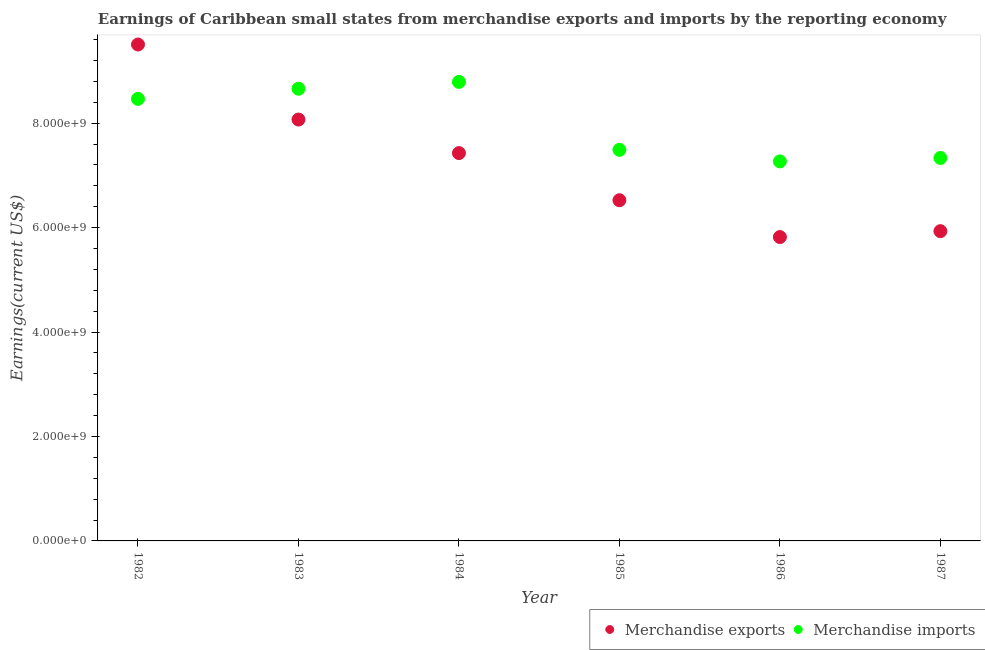What is the earnings from merchandise exports in 1984?
Your answer should be very brief. 7.43e+09. Across all years, what is the maximum earnings from merchandise imports?
Keep it short and to the point. 8.79e+09. Across all years, what is the minimum earnings from merchandise exports?
Your answer should be very brief. 5.82e+09. In which year was the earnings from merchandise exports maximum?
Offer a very short reply. 1982. What is the total earnings from merchandise exports in the graph?
Offer a terse response. 4.33e+1. What is the difference between the earnings from merchandise exports in 1983 and that in 1984?
Your response must be concise. 6.42e+08. What is the difference between the earnings from merchandise imports in 1982 and the earnings from merchandise exports in 1987?
Keep it short and to the point. 2.53e+09. What is the average earnings from merchandise imports per year?
Offer a terse response. 8.00e+09. In the year 1982, what is the difference between the earnings from merchandise imports and earnings from merchandise exports?
Offer a very short reply. -1.04e+09. What is the ratio of the earnings from merchandise exports in 1982 to that in 1983?
Provide a short and direct response. 1.18. Is the earnings from merchandise imports in 1985 less than that in 1987?
Offer a terse response. No. Is the difference between the earnings from merchandise imports in 1983 and 1986 greater than the difference between the earnings from merchandise exports in 1983 and 1986?
Your response must be concise. No. What is the difference between the highest and the second highest earnings from merchandise imports?
Your answer should be compact. 1.31e+08. What is the difference between the highest and the lowest earnings from merchandise imports?
Ensure brevity in your answer.  1.52e+09. In how many years, is the earnings from merchandise exports greater than the average earnings from merchandise exports taken over all years?
Offer a very short reply. 3. Is the sum of the earnings from merchandise exports in 1982 and 1985 greater than the maximum earnings from merchandise imports across all years?
Your answer should be compact. Yes. Is the earnings from merchandise imports strictly greater than the earnings from merchandise exports over the years?
Ensure brevity in your answer.  No. How many dotlines are there?
Provide a succinct answer. 2. How many years are there in the graph?
Your answer should be compact. 6. Are the values on the major ticks of Y-axis written in scientific E-notation?
Your answer should be compact. Yes. Does the graph contain any zero values?
Your response must be concise. No. Where does the legend appear in the graph?
Your answer should be compact. Bottom right. How many legend labels are there?
Give a very brief answer. 2. What is the title of the graph?
Keep it short and to the point. Earnings of Caribbean small states from merchandise exports and imports by the reporting economy. Does "Male population" appear as one of the legend labels in the graph?
Offer a very short reply. No. What is the label or title of the Y-axis?
Ensure brevity in your answer.  Earnings(current US$). What is the Earnings(current US$) of Merchandise exports in 1982?
Your answer should be compact. 9.51e+09. What is the Earnings(current US$) in Merchandise imports in 1982?
Make the answer very short. 8.47e+09. What is the Earnings(current US$) in Merchandise exports in 1983?
Offer a terse response. 8.07e+09. What is the Earnings(current US$) of Merchandise imports in 1983?
Make the answer very short. 8.66e+09. What is the Earnings(current US$) of Merchandise exports in 1984?
Your answer should be compact. 7.43e+09. What is the Earnings(current US$) in Merchandise imports in 1984?
Your answer should be compact. 8.79e+09. What is the Earnings(current US$) of Merchandise exports in 1985?
Your answer should be very brief. 6.53e+09. What is the Earnings(current US$) of Merchandise imports in 1985?
Offer a very short reply. 7.49e+09. What is the Earnings(current US$) in Merchandise exports in 1986?
Your answer should be very brief. 5.82e+09. What is the Earnings(current US$) of Merchandise imports in 1986?
Your response must be concise. 7.27e+09. What is the Earnings(current US$) of Merchandise exports in 1987?
Your answer should be very brief. 5.93e+09. What is the Earnings(current US$) in Merchandise imports in 1987?
Give a very brief answer. 7.33e+09. Across all years, what is the maximum Earnings(current US$) in Merchandise exports?
Keep it short and to the point. 9.51e+09. Across all years, what is the maximum Earnings(current US$) in Merchandise imports?
Keep it short and to the point. 8.79e+09. Across all years, what is the minimum Earnings(current US$) in Merchandise exports?
Your answer should be compact. 5.82e+09. Across all years, what is the minimum Earnings(current US$) in Merchandise imports?
Provide a succinct answer. 7.27e+09. What is the total Earnings(current US$) of Merchandise exports in the graph?
Your answer should be very brief. 4.33e+1. What is the total Earnings(current US$) in Merchandise imports in the graph?
Keep it short and to the point. 4.80e+1. What is the difference between the Earnings(current US$) of Merchandise exports in 1982 and that in 1983?
Keep it short and to the point. 1.44e+09. What is the difference between the Earnings(current US$) of Merchandise imports in 1982 and that in 1983?
Your answer should be very brief. -1.94e+08. What is the difference between the Earnings(current US$) in Merchandise exports in 1982 and that in 1984?
Make the answer very short. 2.08e+09. What is the difference between the Earnings(current US$) of Merchandise imports in 1982 and that in 1984?
Provide a short and direct response. -3.26e+08. What is the difference between the Earnings(current US$) in Merchandise exports in 1982 and that in 1985?
Provide a short and direct response. 2.98e+09. What is the difference between the Earnings(current US$) of Merchandise imports in 1982 and that in 1985?
Offer a terse response. 9.76e+08. What is the difference between the Earnings(current US$) in Merchandise exports in 1982 and that in 1986?
Your response must be concise. 3.69e+09. What is the difference between the Earnings(current US$) in Merchandise imports in 1982 and that in 1986?
Offer a very short reply. 1.20e+09. What is the difference between the Earnings(current US$) in Merchandise exports in 1982 and that in 1987?
Make the answer very short. 3.57e+09. What is the difference between the Earnings(current US$) of Merchandise imports in 1982 and that in 1987?
Give a very brief answer. 1.13e+09. What is the difference between the Earnings(current US$) of Merchandise exports in 1983 and that in 1984?
Your answer should be very brief. 6.42e+08. What is the difference between the Earnings(current US$) of Merchandise imports in 1983 and that in 1984?
Provide a succinct answer. -1.31e+08. What is the difference between the Earnings(current US$) of Merchandise exports in 1983 and that in 1985?
Ensure brevity in your answer.  1.55e+09. What is the difference between the Earnings(current US$) in Merchandise imports in 1983 and that in 1985?
Your answer should be very brief. 1.17e+09. What is the difference between the Earnings(current US$) in Merchandise exports in 1983 and that in 1986?
Keep it short and to the point. 2.25e+09. What is the difference between the Earnings(current US$) in Merchandise imports in 1983 and that in 1986?
Provide a short and direct response. 1.39e+09. What is the difference between the Earnings(current US$) in Merchandise exports in 1983 and that in 1987?
Provide a succinct answer. 2.14e+09. What is the difference between the Earnings(current US$) in Merchandise imports in 1983 and that in 1987?
Your answer should be compact. 1.33e+09. What is the difference between the Earnings(current US$) of Merchandise exports in 1984 and that in 1985?
Give a very brief answer. 9.03e+08. What is the difference between the Earnings(current US$) of Merchandise imports in 1984 and that in 1985?
Make the answer very short. 1.30e+09. What is the difference between the Earnings(current US$) in Merchandise exports in 1984 and that in 1986?
Your response must be concise. 1.61e+09. What is the difference between the Earnings(current US$) in Merchandise imports in 1984 and that in 1986?
Your answer should be compact. 1.52e+09. What is the difference between the Earnings(current US$) of Merchandise exports in 1984 and that in 1987?
Your answer should be compact. 1.50e+09. What is the difference between the Earnings(current US$) of Merchandise imports in 1984 and that in 1987?
Your answer should be very brief. 1.46e+09. What is the difference between the Earnings(current US$) of Merchandise exports in 1985 and that in 1986?
Your answer should be compact. 7.05e+08. What is the difference between the Earnings(current US$) in Merchandise imports in 1985 and that in 1986?
Offer a very short reply. 2.22e+08. What is the difference between the Earnings(current US$) in Merchandise exports in 1985 and that in 1987?
Your response must be concise. 5.92e+08. What is the difference between the Earnings(current US$) in Merchandise imports in 1985 and that in 1987?
Provide a short and direct response. 1.56e+08. What is the difference between the Earnings(current US$) of Merchandise exports in 1986 and that in 1987?
Offer a very short reply. -1.13e+08. What is the difference between the Earnings(current US$) in Merchandise imports in 1986 and that in 1987?
Ensure brevity in your answer.  -6.61e+07. What is the difference between the Earnings(current US$) of Merchandise exports in 1982 and the Earnings(current US$) of Merchandise imports in 1983?
Provide a succinct answer. 8.47e+08. What is the difference between the Earnings(current US$) in Merchandise exports in 1982 and the Earnings(current US$) in Merchandise imports in 1984?
Ensure brevity in your answer.  7.16e+08. What is the difference between the Earnings(current US$) of Merchandise exports in 1982 and the Earnings(current US$) of Merchandise imports in 1985?
Provide a short and direct response. 2.02e+09. What is the difference between the Earnings(current US$) of Merchandise exports in 1982 and the Earnings(current US$) of Merchandise imports in 1986?
Give a very brief answer. 2.24e+09. What is the difference between the Earnings(current US$) in Merchandise exports in 1982 and the Earnings(current US$) in Merchandise imports in 1987?
Ensure brevity in your answer.  2.17e+09. What is the difference between the Earnings(current US$) of Merchandise exports in 1983 and the Earnings(current US$) of Merchandise imports in 1984?
Ensure brevity in your answer.  -7.21e+08. What is the difference between the Earnings(current US$) in Merchandise exports in 1983 and the Earnings(current US$) in Merchandise imports in 1985?
Offer a terse response. 5.80e+08. What is the difference between the Earnings(current US$) of Merchandise exports in 1983 and the Earnings(current US$) of Merchandise imports in 1986?
Make the answer very short. 8.02e+08. What is the difference between the Earnings(current US$) of Merchandise exports in 1983 and the Earnings(current US$) of Merchandise imports in 1987?
Provide a succinct answer. 7.36e+08. What is the difference between the Earnings(current US$) in Merchandise exports in 1984 and the Earnings(current US$) in Merchandise imports in 1985?
Ensure brevity in your answer.  -6.26e+07. What is the difference between the Earnings(current US$) of Merchandise exports in 1984 and the Earnings(current US$) of Merchandise imports in 1986?
Your answer should be compact. 1.59e+08. What is the difference between the Earnings(current US$) of Merchandise exports in 1984 and the Earnings(current US$) of Merchandise imports in 1987?
Your answer should be very brief. 9.32e+07. What is the difference between the Earnings(current US$) of Merchandise exports in 1985 and the Earnings(current US$) of Merchandise imports in 1986?
Offer a very short reply. -7.44e+08. What is the difference between the Earnings(current US$) of Merchandise exports in 1985 and the Earnings(current US$) of Merchandise imports in 1987?
Give a very brief answer. -8.10e+08. What is the difference between the Earnings(current US$) in Merchandise exports in 1986 and the Earnings(current US$) in Merchandise imports in 1987?
Make the answer very short. -1.51e+09. What is the average Earnings(current US$) in Merchandise exports per year?
Provide a succinct answer. 7.21e+09. What is the average Earnings(current US$) in Merchandise imports per year?
Provide a succinct answer. 8.00e+09. In the year 1982, what is the difference between the Earnings(current US$) of Merchandise exports and Earnings(current US$) of Merchandise imports?
Keep it short and to the point. 1.04e+09. In the year 1983, what is the difference between the Earnings(current US$) of Merchandise exports and Earnings(current US$) of Merchandise imports?
Offer a terse response. -5.90e+08. In the year 1984, what is the difference between the Earnings(current US$) in Merchandise exports and Earnings(current US$) in Merchandise imports?
Offer a terse response. -1.36e+09. In the year 1985, what is the difference between the Earnings(current US$) in Merchandise exports and Earnings(current US$) in Merchandise imports?
Provide a short and direct response. -9.66e+08. In the year 1986, what is the difference between the Earnings(current US$) of Merchandise exports and Earnings(current US$) of Merchandise imports?
Offer a terse response. -1.45e+09. In the year 1987, what is the difference between the Earnings(current US$) in Merchandise exports and Earnings(current US$) in Merchandise imports?
Offer a very short reply. -1.40e+09. What is the ratio of the Earnings(current US$) of Merchandise exports in 1982 to that in 1983?
Offer a terse response. 1.18. What is the ratio of the Earnings(current US$) of Merchandise imports in 1982 to that in 1983?
Offer a terse response. 0.98. What is the ratio of the Earnings(current US$) of Merchandise exports in 1982 to that in 1984?
Ensure brevity in your answer.  1.28. What is the ratio of the Earnings(current US$) of Merchandise exports in 1982 to that in 1985?
Your answer should be compact. 1.46. What is the ratio of the Earnings(current US$) in Merchandise imports in 1982 to that in 1985?
Provide a short and direct response. 1.13. What is the ratio of the Earnings(current US$) of Merchandise exports in 1982 to that in 1986?
Keep it short and to the point. 1.63. What is the ratio of the Earnings(current US$) in Merchandise imports in 1982 to that in 1986?
Your response must be concise. 1.16. What is the ratio of the Earnings(current US$) in Merchandise exports in 1982 to that in 1987?
Ensure brevity in your answer.  1.6. What is the ratio of the Earnings(current US$) in Merchandise imports in 1982 to that in 1987?
Provide a succinct answer. 1.15. What is the ratio of the Earnings(current US$) of Merchandise exports in 1983 to that in 1984?
Offer a terse response. 1.09. What is the ratio of the Earnings(current US$) of Merchandise imports in 1983 to that in 1984?
Your response must be concise. 0.99. What is the ratio of the Earnings(current US$) in Merchandise exports in 1983 to that in 1985?
Make the answer very short. 1.24. What is the ratio of the Earnings(current US$) in Merchandise imports in 1983 to that in 1985?
Give a very brief answer. 1.16. What is the ratio of the Earnings(current US$) in Merchandise exports in 1983 to that in 1986?
Ensure brevity in your answer.  1.39. What is the ratio of the Earnings(current US$) in Merchandise imports in 1983 to that in 1986?
Ensure brevity in your answer.  1.19. What is the ratio of the Earnings(current US$) of Merchandise exports in 1983 to that in 1987?
Make the answer very short. 1.36. What is the ratio of the Earnings(current US$) of Merchandise imports in 1983 to that in 1987?
Offer a very short reply. 1.18. What is the ratio of the Earnings(current US$) in Merchandise exports in 1984 to that in 1985?
Make the answer very short. 1.14. What is the ratio of the Earnings(current US$) of Merchandise imports in 1984 to that in 1985?
Provide a succinct answer. 1.17. What is the ratio of the Earnings(current US$) in Merchandise exports in 1984 to that in 1986?
Provide a succinct answer. 1.28. What is the ratio of the Earnings(current US$) of Merchandise imports in 1984 to that in 1986?
Your answer should be compact. 1.21. What is the ratio of the Earnings(current US$) of Merchandise exports in 1984 to that in 1987?
Your answer should be compact. 1.25. What is the ratio of the Earnings(current US$) of Merchandise imports in 1984 to that in 1987?
Offer a terse response. 1.2. What is the ratio of the Earnings(current US$) in Merchandise exports in 1985 to that in 1986?
Your answer should be very brief. 1.12. What is the ratio of the Earnings(current US$) of Merchandise imports in 1985 to that in 1986?
Your answer should be compact. 1.03. What is the ratio of the Earnings(current US$) in Merchandise exports in 1985 to that in 1987?
Ensure brevity in your answer.  1.1. What is the ratio of the Earnings(current US$) of Merchandise imports in 1985 to that in 1987?
Keep it short and to the point. 1.02. What is the ratio of the Earnings(current US$) of Merchandise imports in 1986 to that in 1987?
Offer a terse response. 0.99. What is the difference between the highest and the second highest Earnings(current US$) of Merchandise exports?
Provide a short and direct response. 1.44e+09. What is the difference between the highest and the second highest Earnings(current US$) of Merchandise imports?
Provide a succinct answer. 1.31e+08. What is the difference between the highest and the lowest Earnings(current US$) in Merchandise exports?
Ensure brevity in your answer.  3.69e+09. What is the difference between the highest and the lowest Earnings(current US$) of Merchandise imports?
Give a very brief answer. 1.52e+09. 